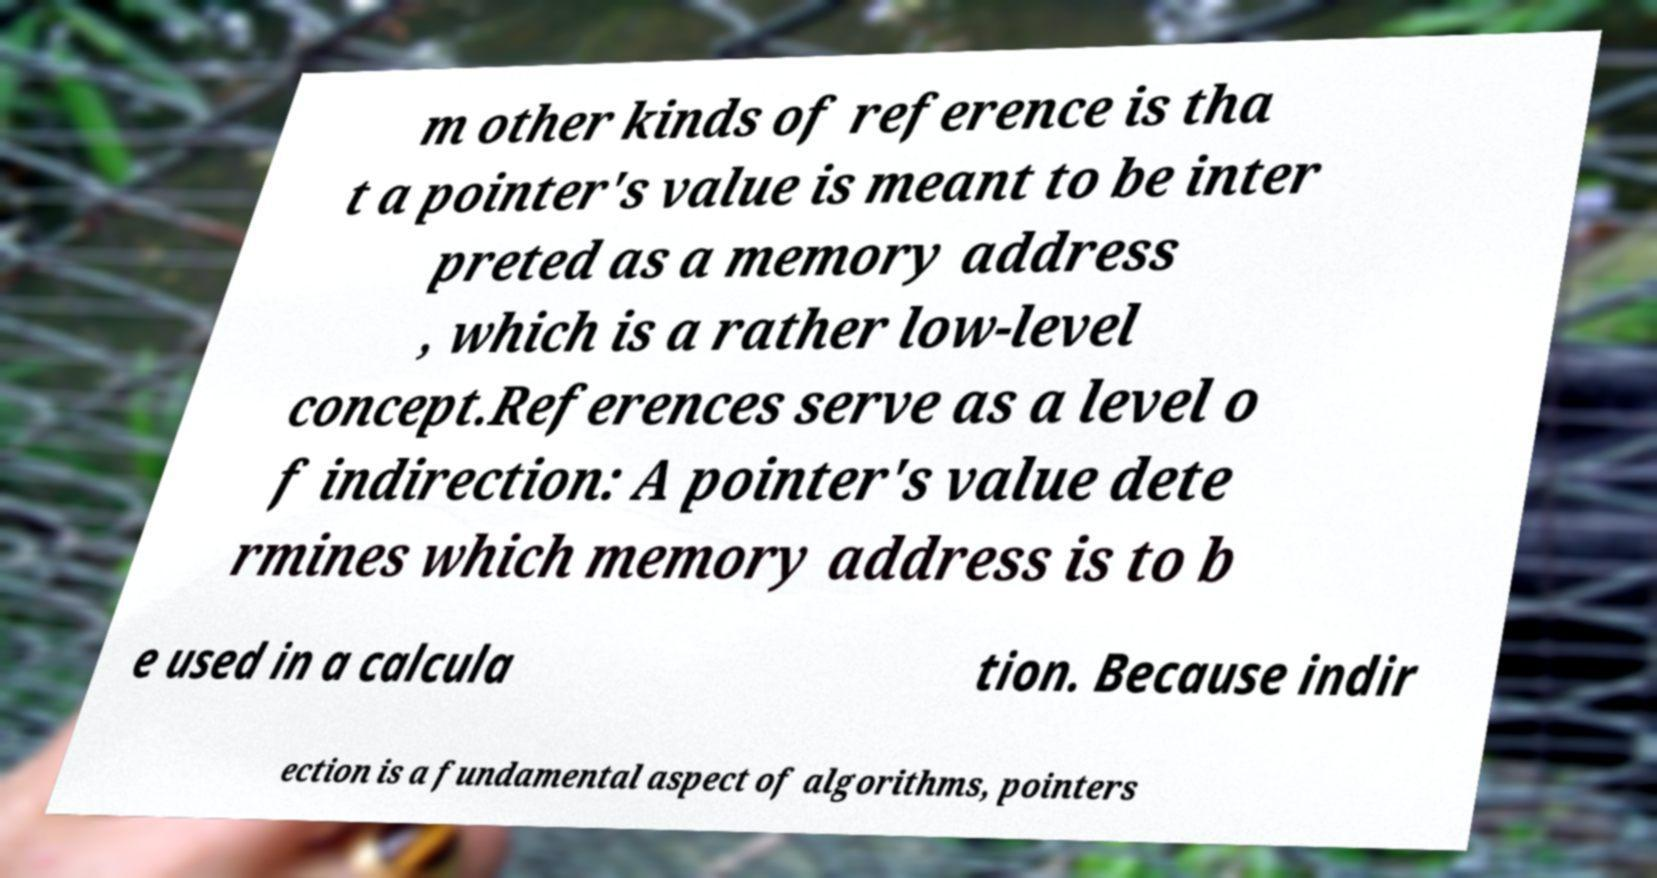Can you read and provide the text displayed in the image?This photo seems to have some interesting text. Can you extract and type it out for me? m other kinds of reference is tha t a pointer's value is meant to be inter preted as a memory address , which is a rather low-level concept.References serve as a level o f indirection: A pointer's value dete rmines which memory address is to b e used in a calcula tion. Because indir ection is a fundamental aspect of algorithms, pointers 